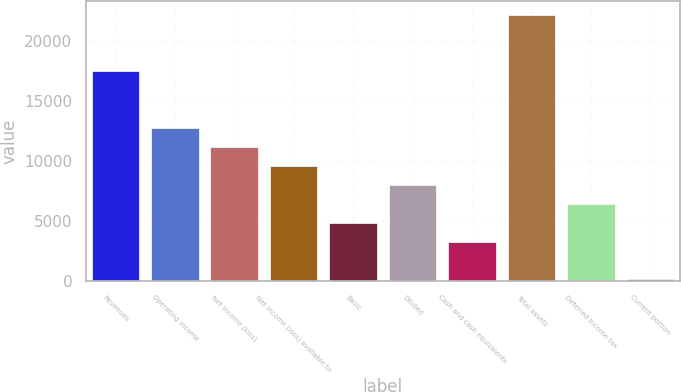Convert chart. <chart><loc_0><loc_0><loc_500><loc_500><bar_chart><fcel>Revenues<fcel>Operating income<fcel>Net income (loss)<fcel>Net income (loss) available to<fcel>Basic<fcel>Diluted<fcel>Cash and cash equivalents<fcel>Total assets<fcel>Deferred income tax<fcel>Current portion<nl><fcel>17438.5<fcel>12715<fcel>11140.5<fcel>9566<fcel>4842.5<fcel>7991.5<fcel>3268<fcel>22162<fcel>6417<fcel>119<nl></chart> 